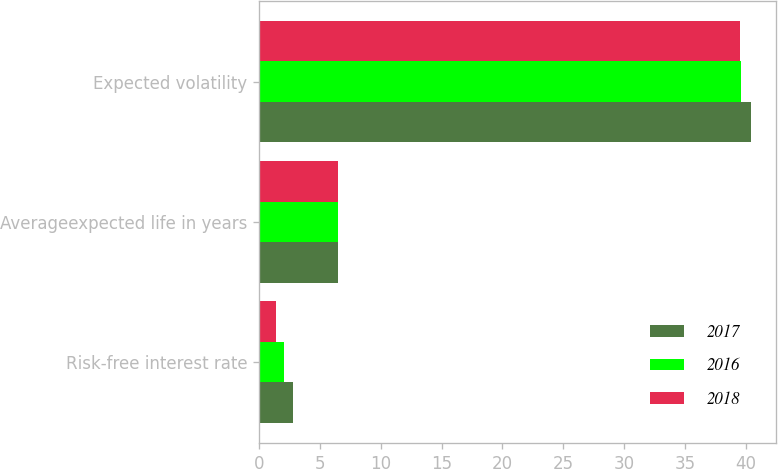Convert chart to OTSL. <chart><loc_0><loc_0><loc_500><loc_500><stacked_bar_chart><ecel><fcel>Risk-free interest rate<fcel>Averageexpected life in years<fcel>Expected volatility<nl><fcel>2017<fcel>2.8<fcel>6.5<fcel>40.4<nl><fcel>2016<fcel>2.1<fcel>6.5<fcel>39.6<nl><fcel>2018<fcel>1.4<fcel>6.5<fcel>39.5<nl></chart> 